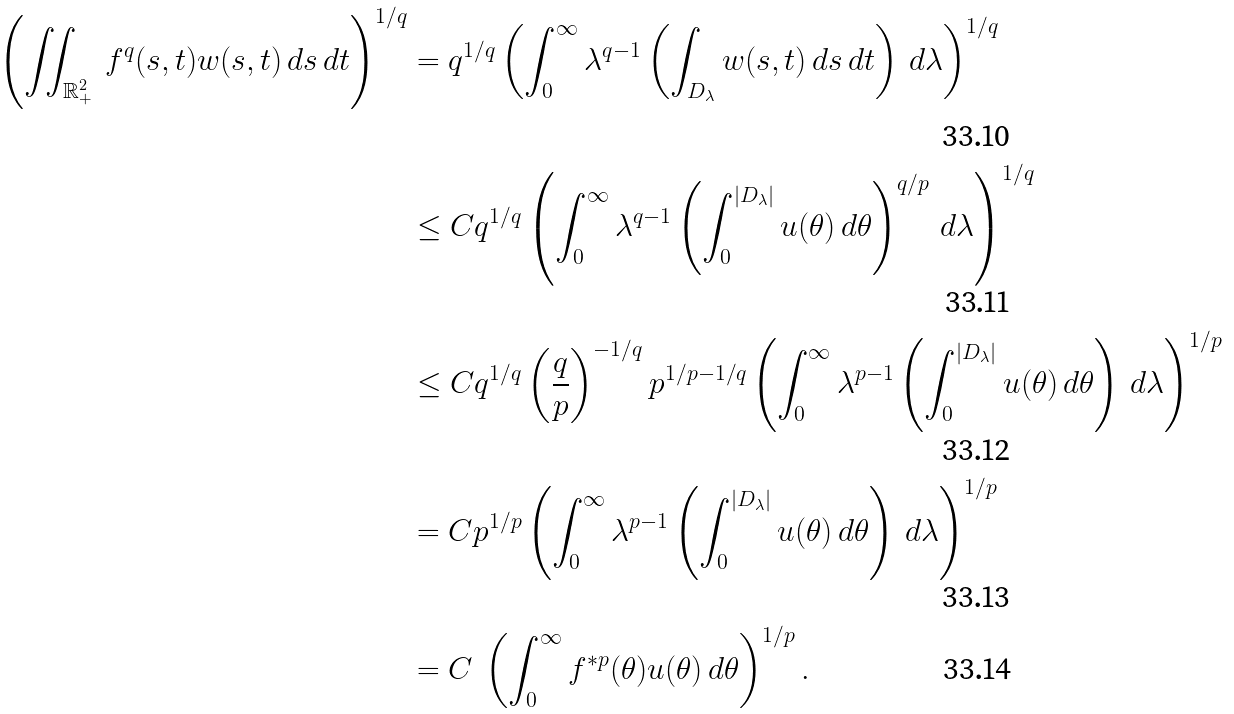<formula> <loc_0><loc_0><loc_500><loc_500>\left ( \iint _ { \mathbb { R } ^ { 2 } _ { + } } \ f ^ { q } ( s , t ) w ( s , t ) \, d s \, d t \right ) ^ { 1 / q } & = q ^ { 1 / q } \left ( \int _ { 0 } ^ { \infty } \lambda ^ { q - 1 } \left ( \int _ { D _ { \lambda } } w ( s , t ) \, d s \, d t \right ) \, d \lambda \right ) ^ { 1 / q } \\ & \leq C q ^ { 1 / q } \left ( \int _ { 0 } ^ { \infty } \lambda ^ { q - 1 } \left ( \int _ { 0 } ^ { \left | D _ { \lambda } \right | } u ( \theta ) \, d \theta \right ) ^ { q / p } \, d \lambda \right ) ^ { 1 / q } \\ & \leq C q ^ { 1 / q } \left ( \frac { q } { p } \right ) ^ { - 1 / q } p ^ { 1 / p - 1 / q } \left ( \int _ { 0 } ^ { \infty } \lambda ^ { p - 1 } \left ( \int _ { 0 } ^ { \left | D _ { \lambda } \right | } u ( \theta ) \, d \theta \right ) \, d \lambda \right ) ^ { 1 / p } \\ & = C p ^ { 1 / p } \left ( \int _ { 0 } ^ { \infty } \lambda ^ { p - 1 } \left ( \int _ { 0 } ^ { \left | D _ { \lambda } \right | } u ( \theta ) \, d \theta \right ) \, d \lambda \right ) ^ { 1 / p } \\ & = C \ \left ( \int _ { 0 } ^ { \infty } f ^ { \ast p } ( \theta ) u ( \theta ) \, d \theta \right ) ^ { 1 / p } .</formula> 